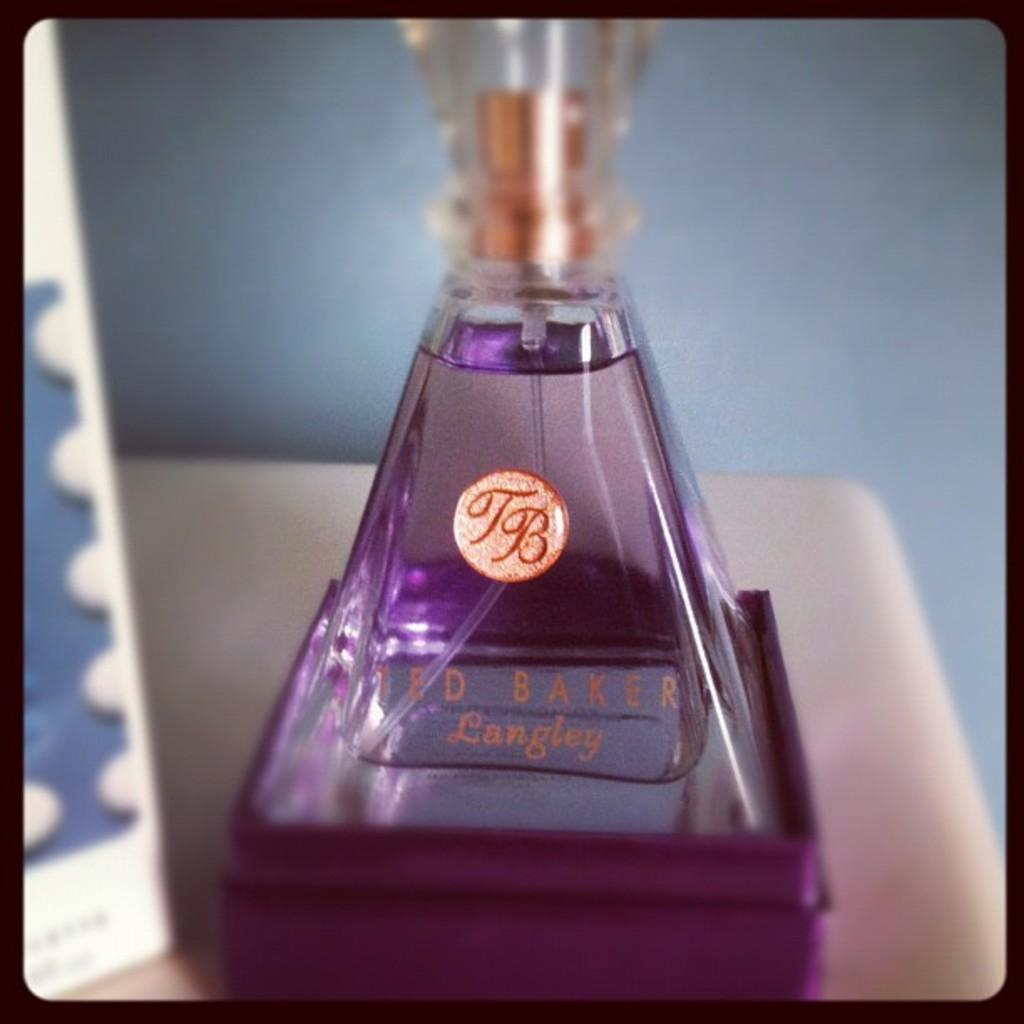<image>
Create a compact narrative representing the image presented. A jar of perfume that says Ted Baker Langley. 